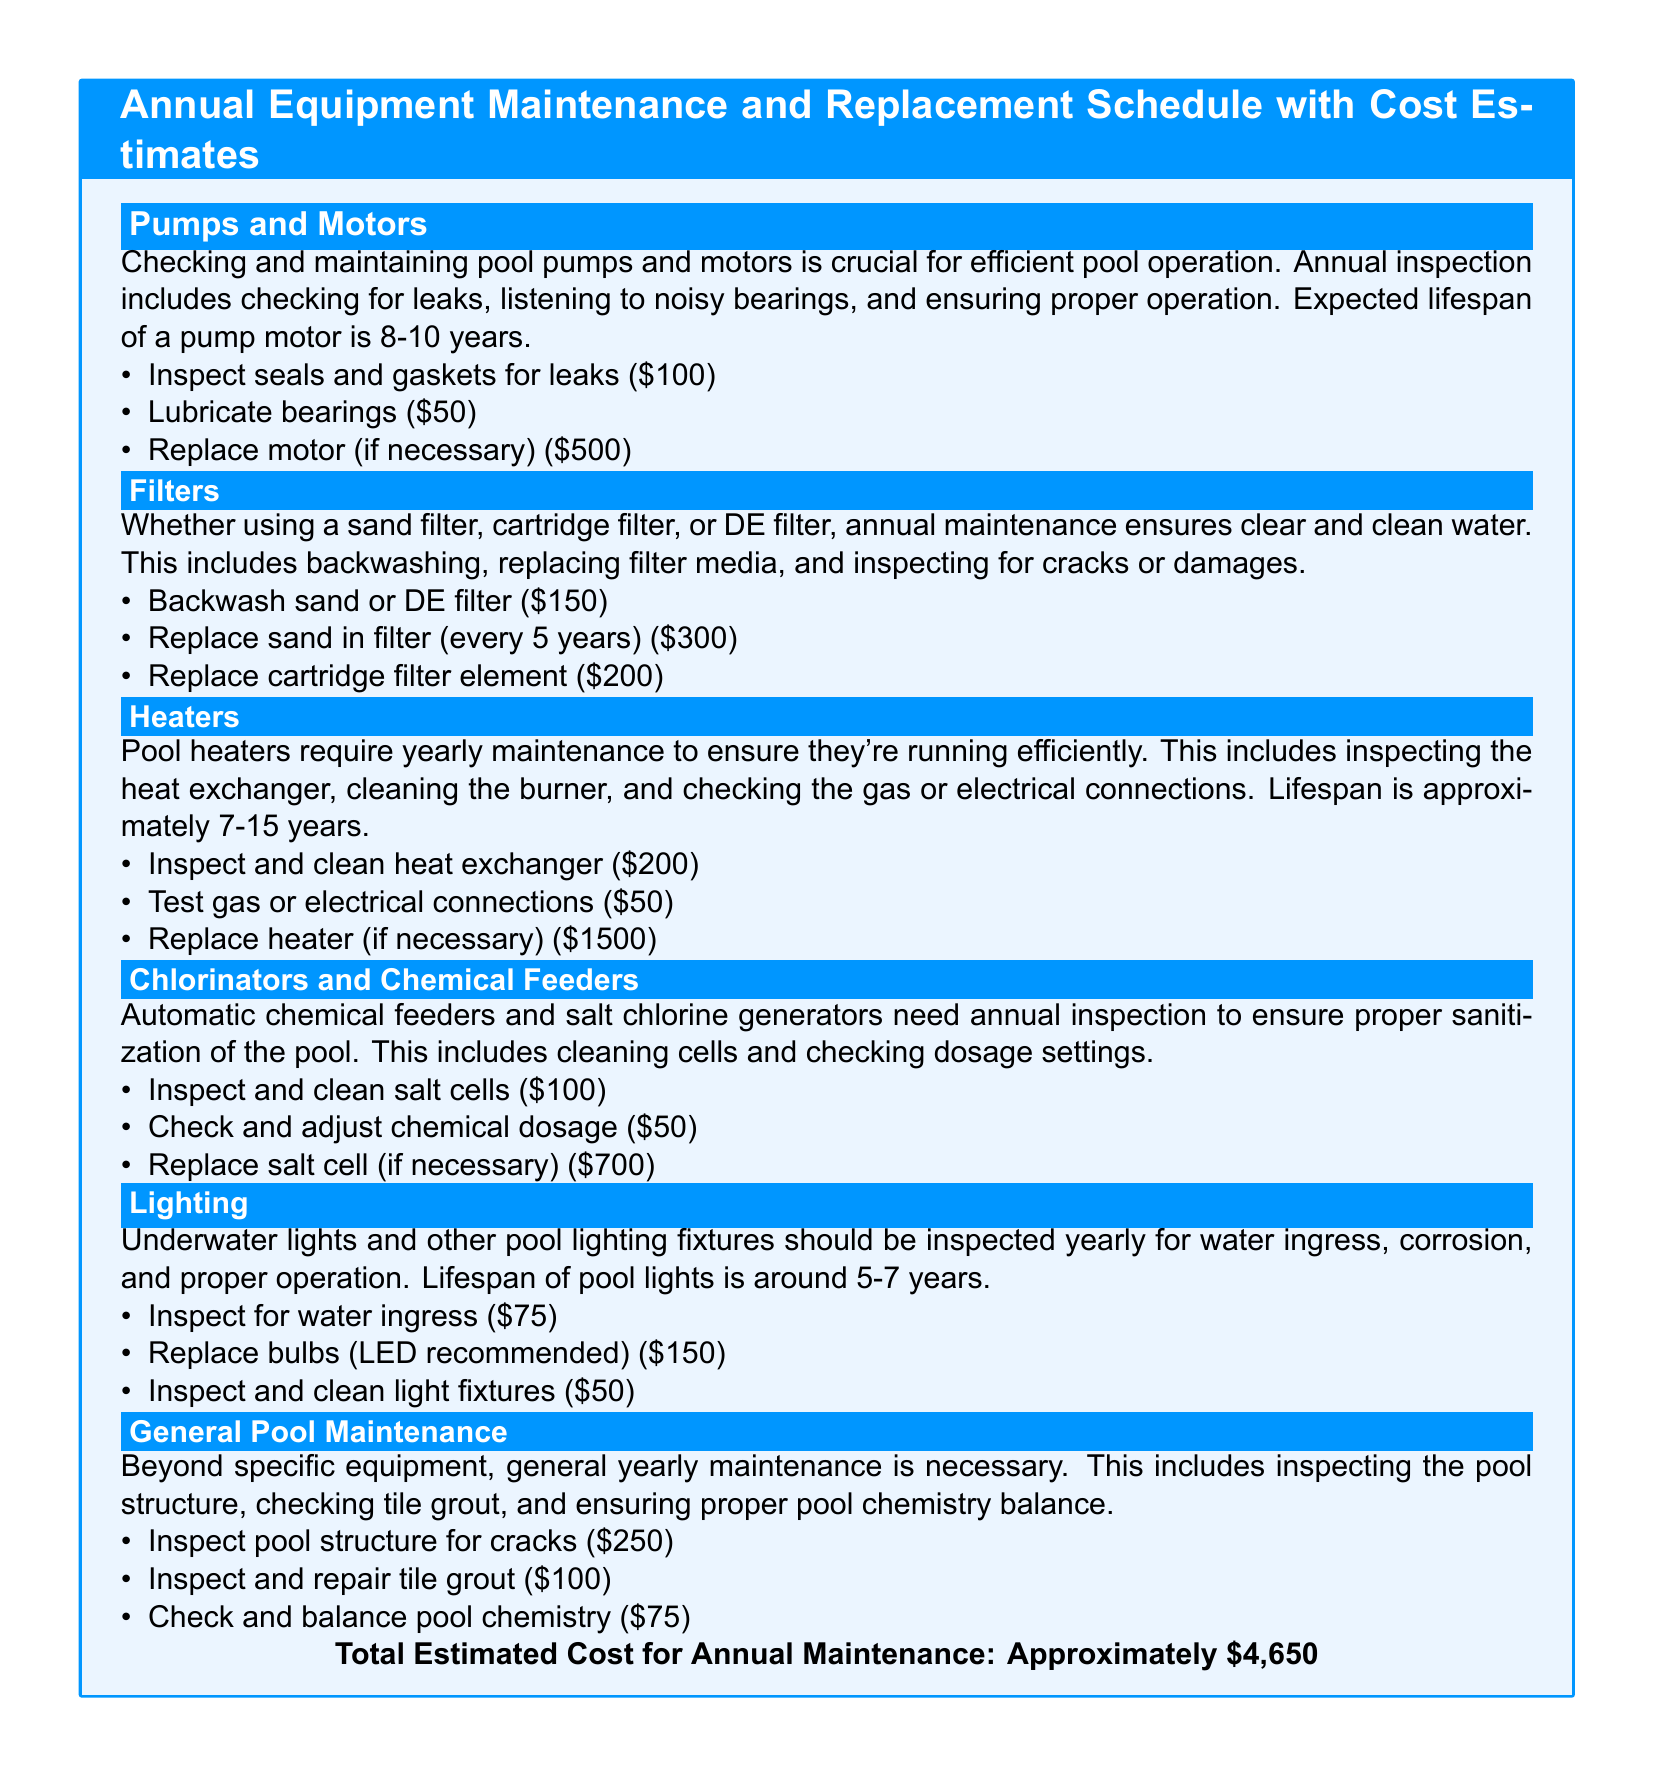What is the lifespan of a pump motor? The document states the expected lifespan of a pump motor is 8-10 years.
Answer: 8-10 years How much does it cost to replace a heater? The cost to replace a heater is listed as $1500 in the document.
Answer: $1500 What maintenance is done for filters? The document outlines that annual maintenance for filters includes backwashing, replacing filter media, and inspecting for cracks or damages.
Answer: Backwashing, replacing filter media, inspecting What is the total estimated cost for annual maintenance? The total estimated cost for annual maintenance is provided at the end of the document and is approximately $4,650.
Answer: Approximately $4,650 What is inspected for chlorinators and chemical feeders? The document mentions inspecting and cleaning salt cells and checking dosage settings as part of the maintenance tasks.
Answer: Salt cells, dosage settings How much does it cost to lubricate bearings? The cost to lubricate bearings is $50 according to the tasks listed in the document.
Answer: $50 What is the primary purpose of annual pool maintenance? The document indicates that annual pool maintenance is necessary to ensure efficient pool operation and maintenance of water quality.
Answer: Efficient pool operation, water quality How much does it cost to inspect the pool structure for cracks? The cost for inspecting the pool structure for cracks is $250 as stated in the document.
Answer: $250 